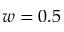Convert formula to latex. <formula><loc_0><loc_0><loc_500><loc_500>w = 0 . 5</formula> 